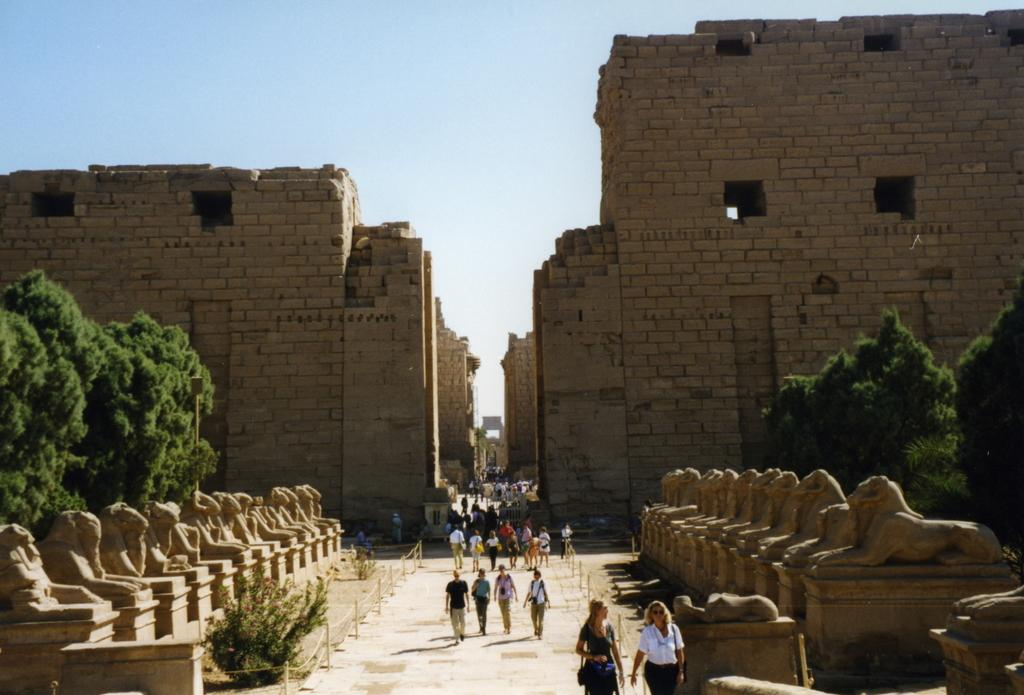What are the people in the image doing? The people in the image are walking on the road. What is the setting of the road in the image? The road is in the middle of trees. What artistic elements can be seen in the image? Sculptures are present in the image. What type of structure is visible in the image? There is a building in the image. What type of texture can be seen on the pump in the image? There is no pump present in the image, so it is not possible to determine the texture. What type of wool is used to make the clothing of the people walking on the road? There is no information about the clothing of the people walking on the road, nor is there any mention of wool in the image. 